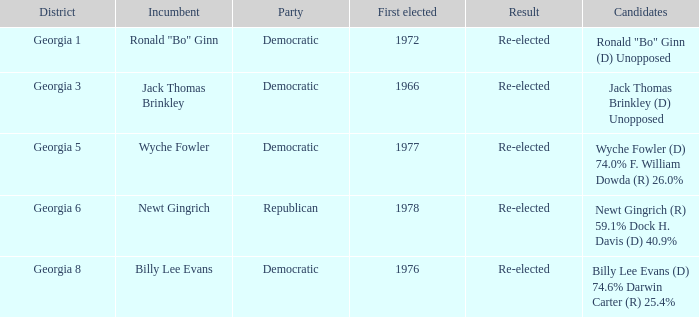How many candidates were first elected in 1972? 1.0. 